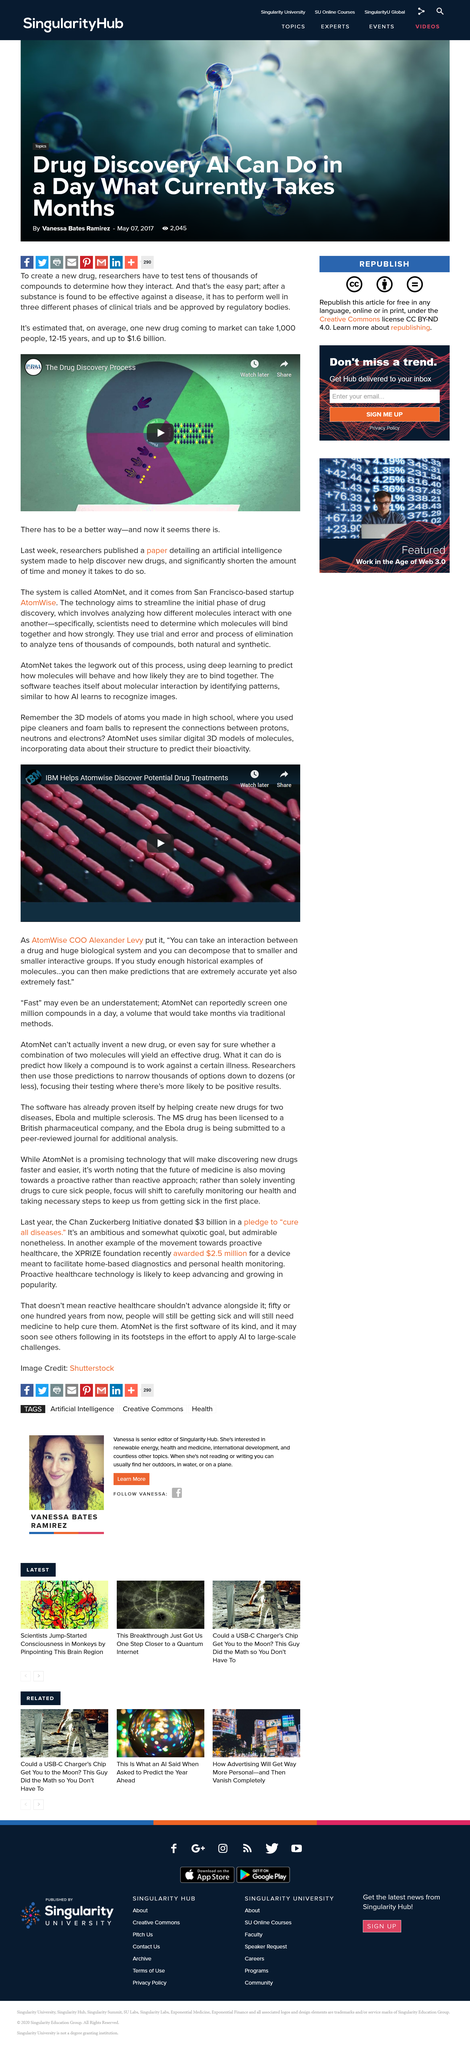Mention a couple of crucial points in this snapshot. AtomWise aims to predict the interactions between drugs and biological systems through the modeling of molecules. This is done in order to identify potential drug treatments. Alexander Levy is the Chief Operating Officer of AtomWise. Yes, AtomWise relies on AI technology for its process, and it utilizes AI learning to enhance its capabilities. 